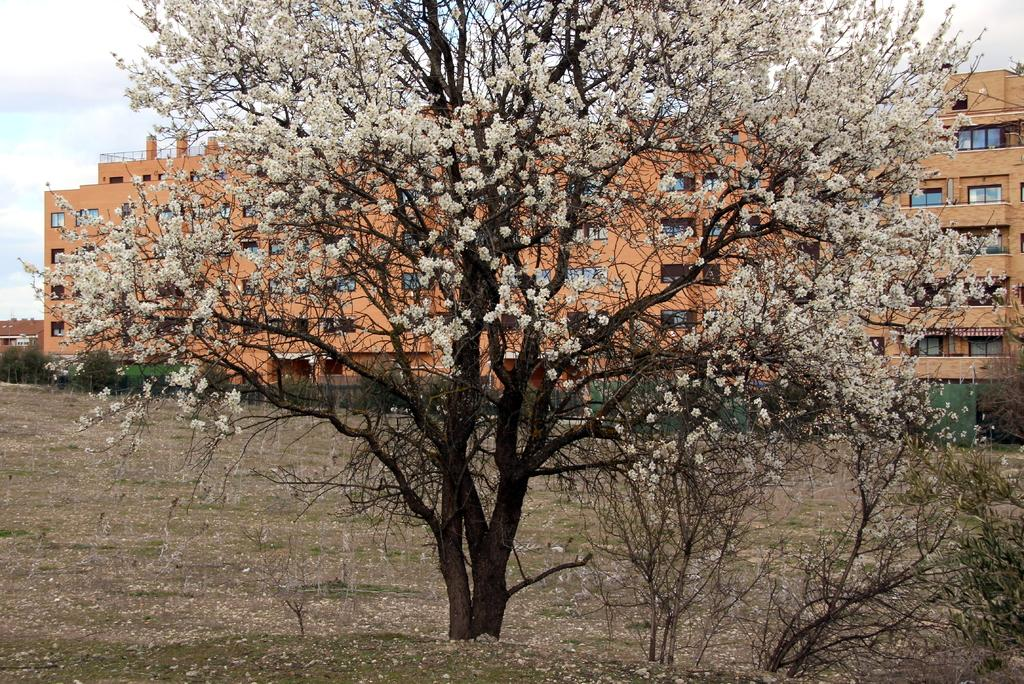What type of vegetation can be seen in the image? There are trees and flowers in the image. What is visible on the ground in the image? The ground is visible in the image. What type of structures are present in the image? There are buildings in the image. What can be seen in the background of the image? The sky is visible in the background of the image, and there are clouds in the sky. Can you tell me how the woman is expressing her anger in the image? There is no woman present in the image, nor is there any indication of anger. 